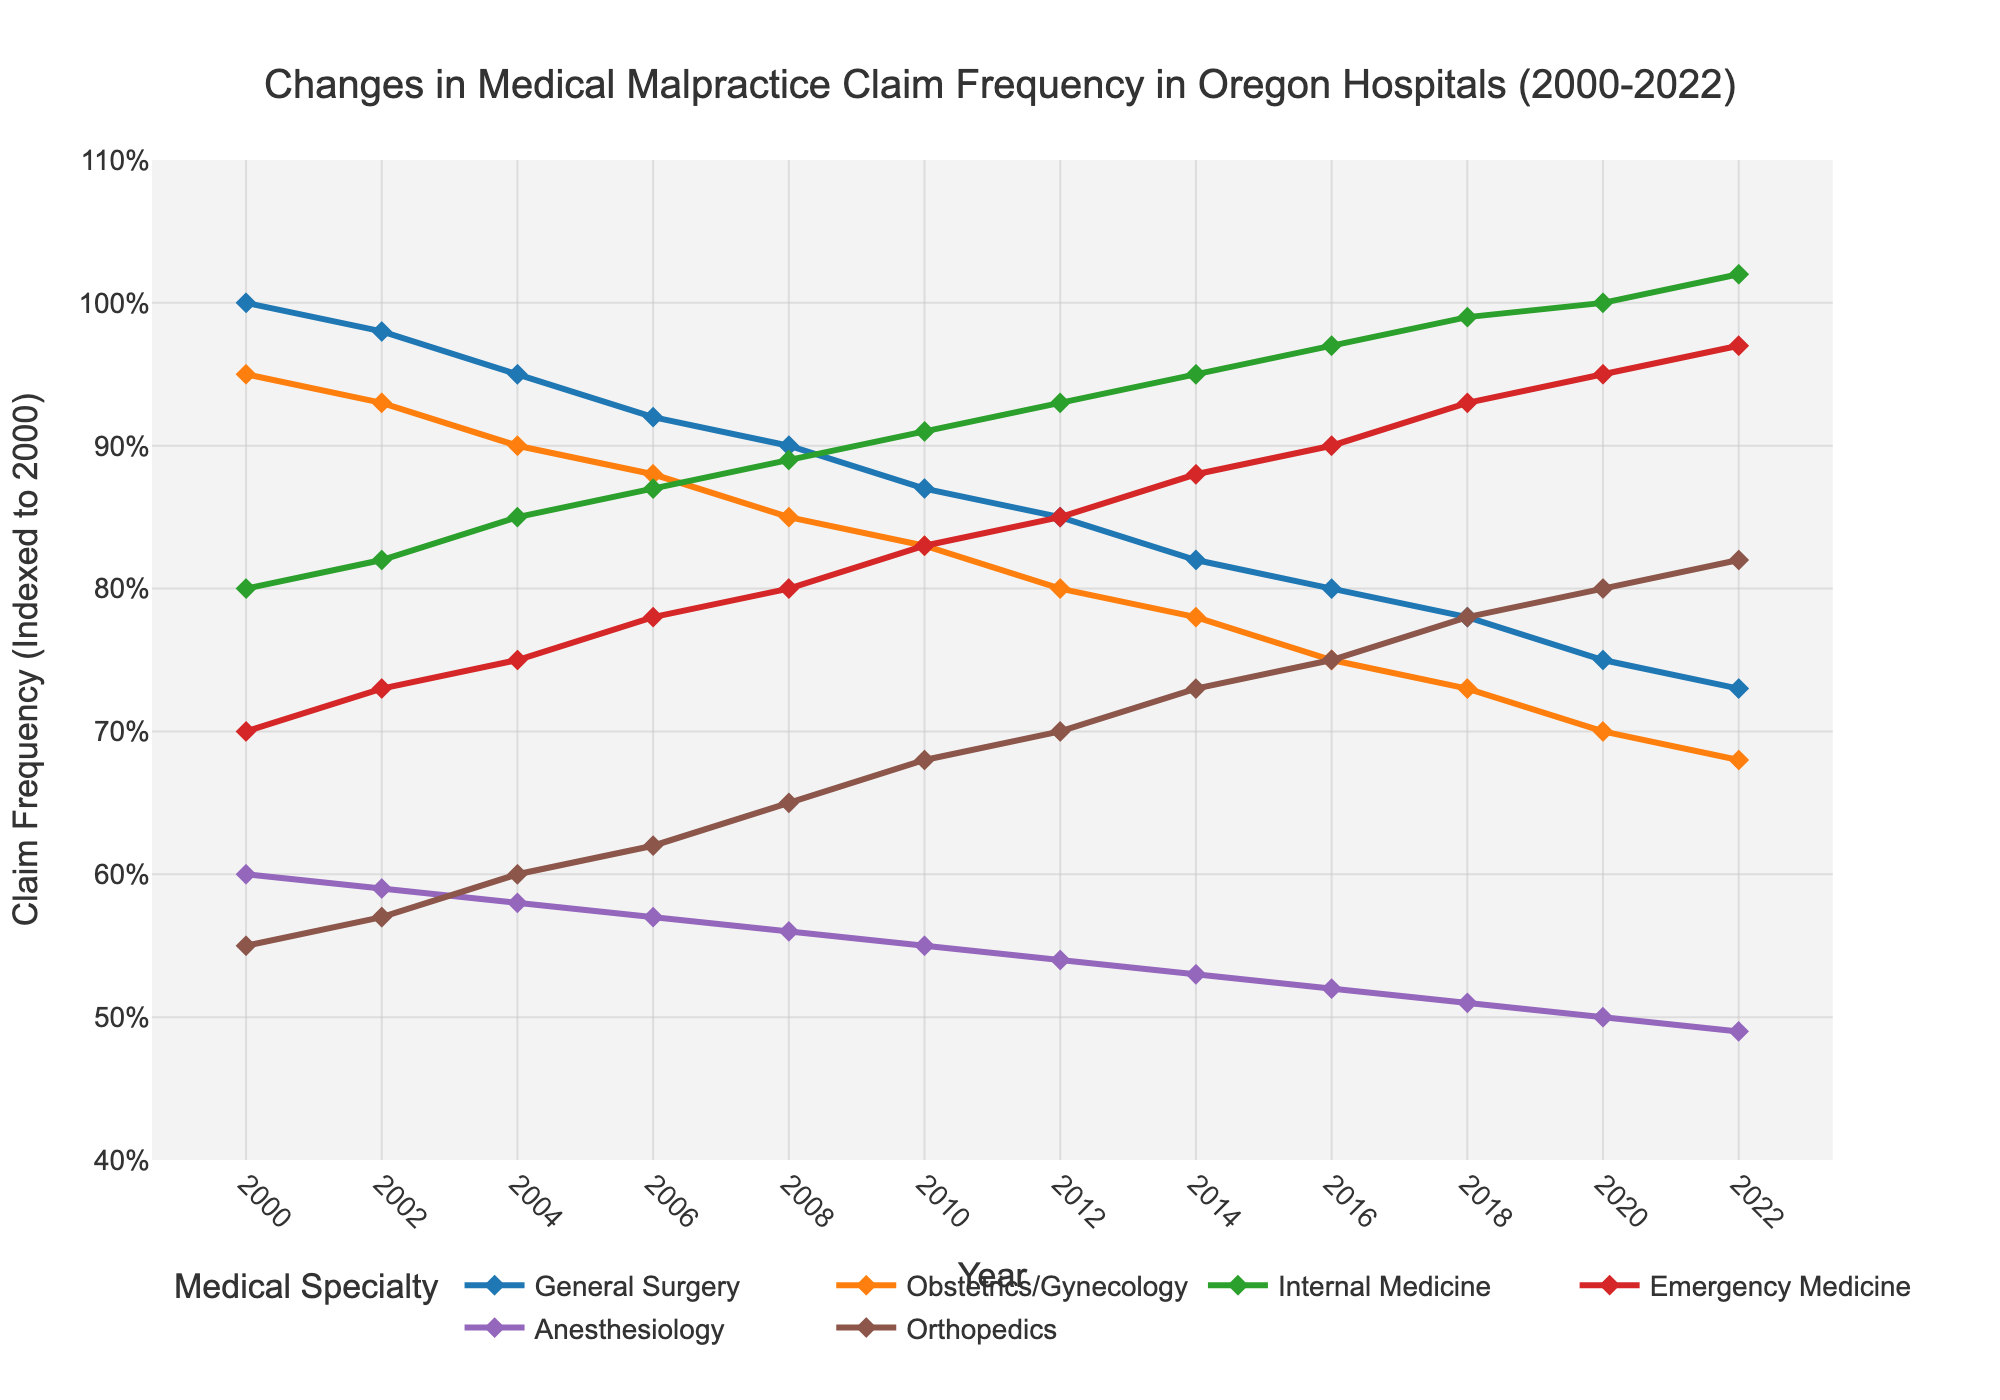What's the trend for malpractice claims in General Surgery from 2000 to 2022? The malpractice claims in General Surgery show a declining trend. Initially, the claims are at 100 in 2000 and decrease steadily to 73 by 2022.
Answer: Declining Which specialty saw the highest increase in malpractice claims from 2000 to 2022? Internal Medicine saw the highest increase in malpractice claims, starting at 80 in 2000 and increasing to 102 in 2022.
Answer: Internal Medicine What is the difference in malpractice claims for Emergency Medicine between 2008 and 2018? In 2008, Emergency Medicine had 80 claims, and in 2018, it had 93 claims. The difference is 93 - 80 = 13.
Answer: 13 Among the specialties, which one had the least change in malpractice claims from 2000 to 2022? Anesthesiology had the least change in malpractice claims, starting at 60 in 2000 and reducing to 49 in 2022.
Answer: Anesthesiology By examining the trend lines, which specialty maintained the most consistent increase in malpractice claims? Internal Medicine shows a consistent increase in malpractice claims over the years without any dips.
Answer: Internal Medicine In 2016, which specialties had fewer malpractice claims than General Surgery? In 2016, General Surgery had 80 claims. The specialties with fewer claims are Obstetrics/Gynecology (75), Anesthesiology (52), and Orthopedics (75).
Answer: Obstetrics/Gynecology, Anesthesiology, Orthopedics What are the malpractice claims for Orthopedics in 2012 and 2018, and what's the average of these claims? In 2012, Orthopedics had 70 claims, and in 2018, it had 78 claims. The average is (70 + 78) / 2 = 74.
Answer: 74 How does the claim frequency in Obstetrics/Gynecology in 2000 compare to 2022? In 2000, Obstetrics/Gynecology had 95 claims, and in 2022, it had 68 claims. The claim frequency decreased by 95 - 68 = 27.
Answer: Decreased by 27 If you sum the malpractice claims for General Surgery, Obstetrics/Gynecology, and Internal Medicine in 2010, what is the total? In 2010, the claims were 87 for General Surgery, 83 for Obstetrics/Gynecology, and 91 for Internal Medicine. The total is 87 + 83 + 91 = 261.
Answer: 261 Which specialty had the highest claim frequency in 2020? In 2020, Internal Medicine had the highest claim frequency at 100.
Answer: Internal Medicine 